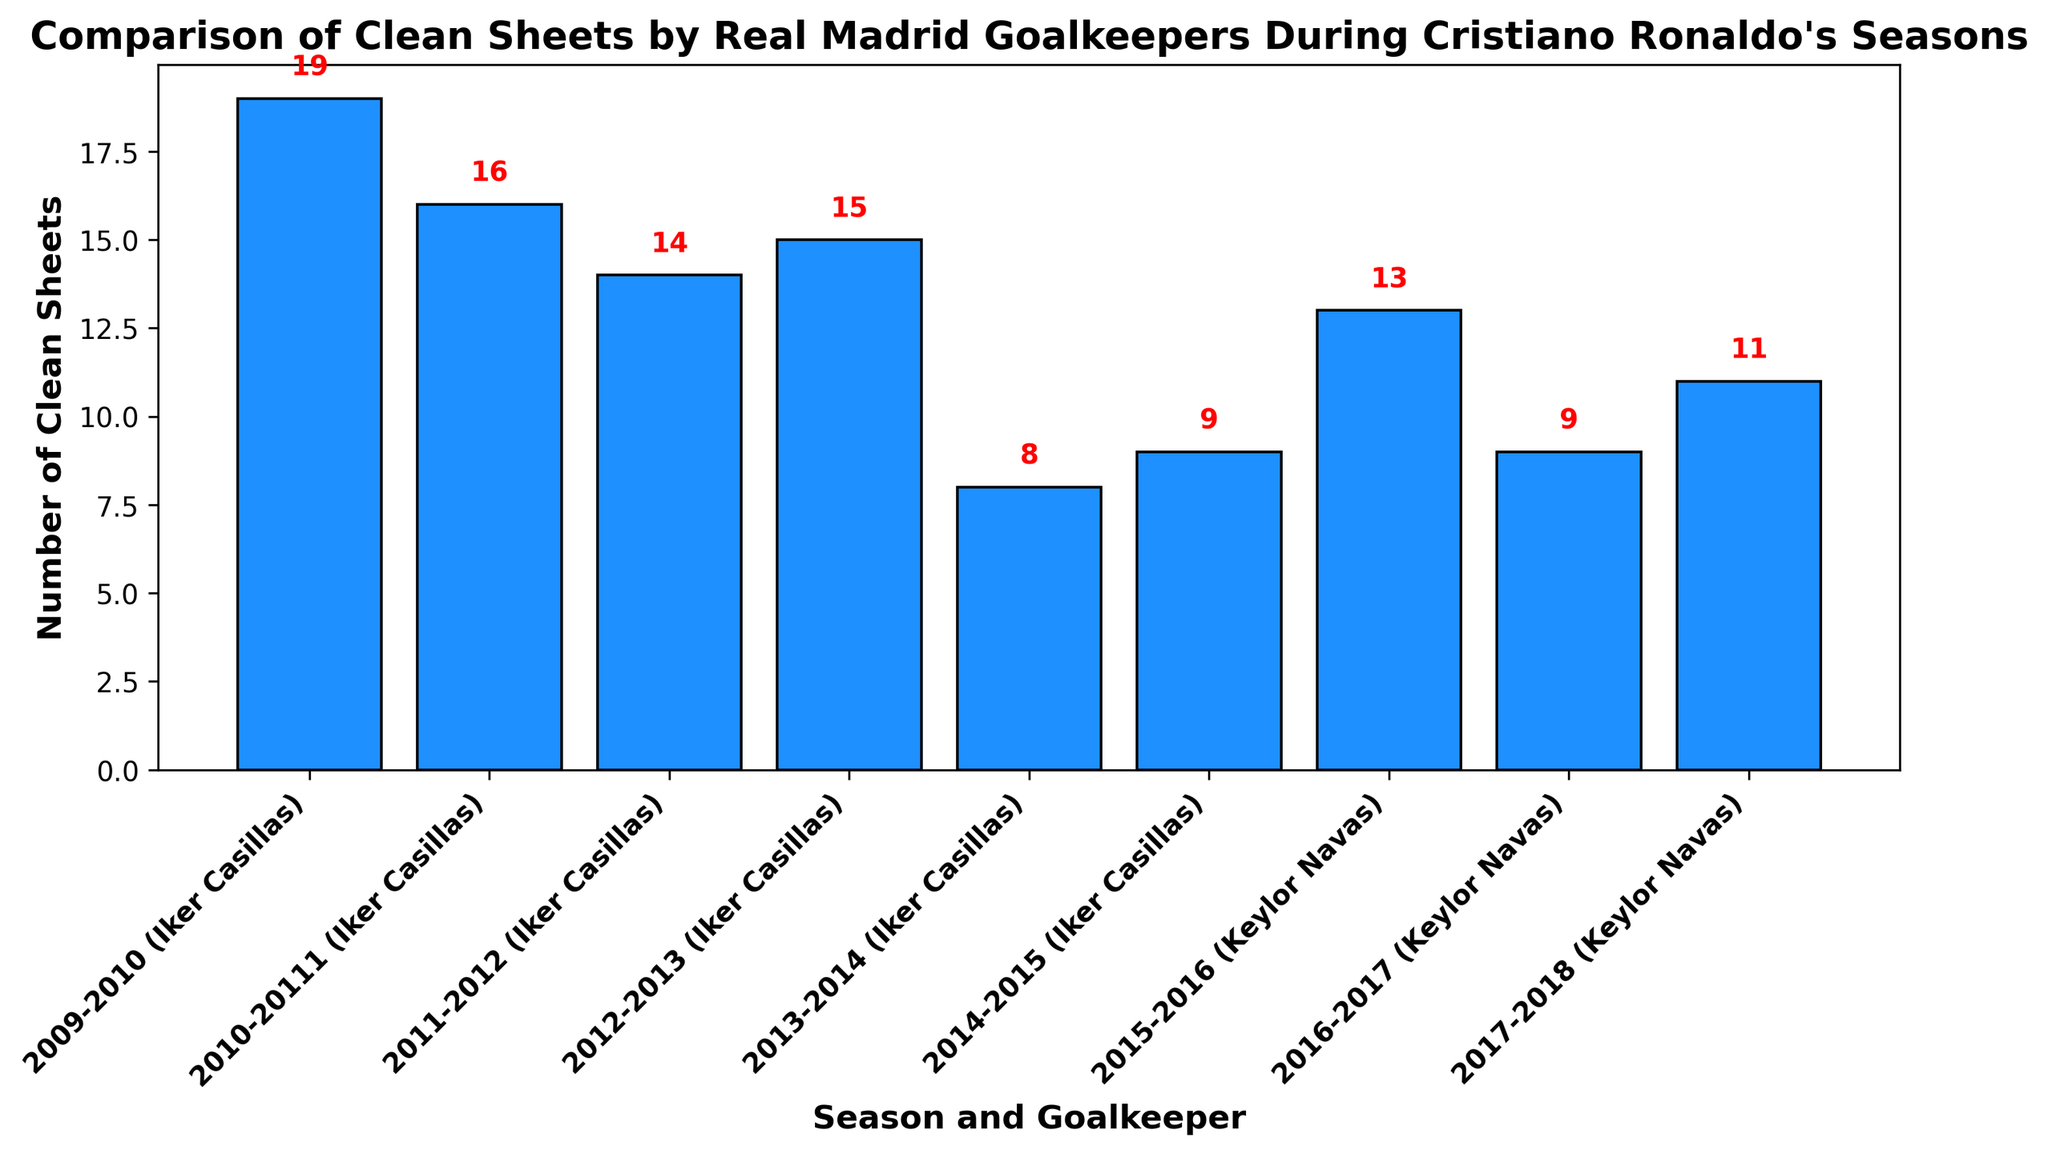Which season had the highest number of clean sheets? Look at the highest bar in the chart, which corresponds to the number of clean sheets.
Answer: 2009-2010 Which goalkeeper recorded more clean sheets in the 2013-2014 season? Identify the goalkeeper listed for the season 2013-2014 and note the number of clean sheets.
Answer: Iker Casillas How many more clean sheets did Iker Casillas have in 2009-2010 compared to 2013-2014? The number of clean sheets in 2009-2010 is 19, and in 2013-2014 it is 8. Subtract the latter from the former to find the difference. 19 - 8 = 11
Answer: 11 Which season among Iker Casillas' records had the least number of clean sheets? Look at all the bars corresponding to Iker Casillas and find the lowest one in terms of height.
Answer: 2013-2014 Who had the highest average number of clean sheets, Iker Casillas or Keylor Navas? Calculate the average for each goalkeeper and compare. Iker Casillas: (19 + 16 + 14 + 15 + 8 + 9) / 6 = 13.5. Keylor Navas: (13 + 9 + 11) / 3 = 11. Therefore, Iker Casillas has a higher average.
Answer: Iker Casillas In which season did Keylor Navas have the fewest clean sheets? Look for the lowest bar among those representing Keylor Navas' seasons and note the corresponding season.
Answer: 2016-2017 What is the difference between the clean sheets of Keylor Navas in 2015-2016 and Iker Casillas in 2011-2012? The number of clean sheets for Keylor Navas in 2015-2016 is 13, and for Iker Casillas in 2011-2012 it is 14. Subtract the former from the latter: 14 - 13 = 1.
Answer: 1 Which goalkeeper had the most varied performance in terms of clean sheets across the seasons shown? Identify the goalkeeper with the highest range (difference between max and min clean sheets). Iker Casillas: 19 - 8 = 11. Keylor Navas: 13 - 9 = 4. Therefore, Iker Casillas had the most varied performance.
Answer: Iker Casillas What's the total number of clean sheets by Iker Casillas during Cristiano Ronaldo's seasons at Real Madrid? Sum up all the clean sheets recorded by Iker Casillas: 19 + 16 + 14 + 15 + 8 + 9 = 81.
Answer: 81 